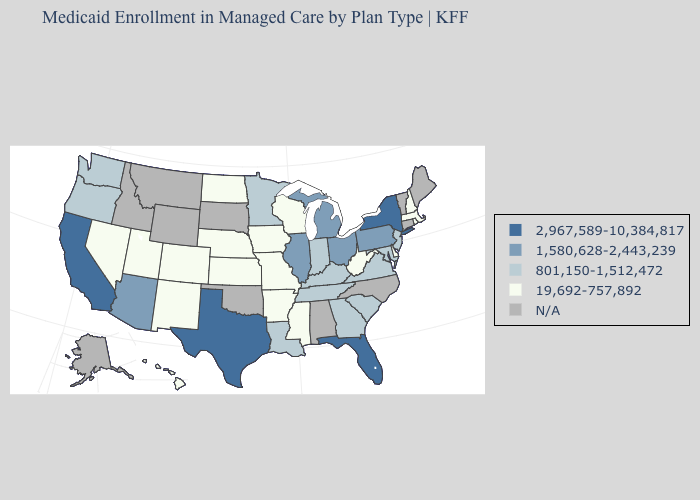Which states have the lowest value in the MidWest?
Answer briefly. Iowa, Kansas, Missouri, Nebraska, North Dakota, Wisconsin. Which states have the lowest value in the USA?
Concise answer only. Arkansas, Colorado, Delaware, Hawaii, Iowa, Kansas, Massachusetts, Mississippi, Missouri, Nebraska, Nevada, New Hampshire, New Mexico, North Dakota, Rhode Island, Utah, West Virginia, Wisconsin. Which states have the highest value in the USA?
Concise answer only. California, Florida, New York, Texas. Among the states that border Missouri , does Arkansas have the highest value?
Be succinct. No. Name the states that have a value in the range N/A?
Be succinct. Alabama, Alaska, Connecticut, Idaho, Maine, Montana, North Carolina, Oklahoma, South Dakota, Vermont, Wyoming. Does the first symbol in the legend represent the smallest category?
Give a very brief answer. No. Does New York have the highest value in the Northeast?
Quick response, please. Yes. Does the map have missing data?
Write a very short answer. Yes. Which states have the lowest value in the MidWest?
Be succinct. Iowa, Kansas, Missouri, Nebraska, North Dakota, Wisconsin. How many symbols are there in the legend?
Quick response, please. 5. What is the highest value in the Northeast ?
Be succinct. 2,967,589-10,384,817. Name the states that have a value in the range 19,692-757,892?
Be succinct. Arkansas, Colorado, Delaware, Hawaii, Iowa, Kansas, Massachusetts, Mississippi, Missouri, Nebraska, Nevada, New Hampshire, New Mexico, North Dakota, Rhode Island, Utah, West Virginia, Wisconsin. Name the states that have a value in the range 2,967,589-10,384,817?
Concise answer only. California, Florida, New York, Texas. Name the states that have a value in the range 1,580,628-2,443,239?
Short answer required. Arizona, Illinois, Michigan, Ohio, Pennsylvania. Name the states that have a value in the range 19,692-757,892?
Keep it brief. Arkansas, Colorado, Delaware, Hawaii, Iowa, Kansas, Massachusetts, Mississippi, Missouri, Nebraska, Nevada, New Hampshire, New Mexico, North Dakota, Rhode Island, Utah, West Virginia, Wisconsin. 